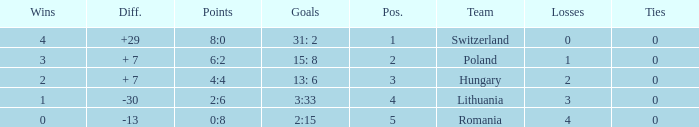Which team had fewer than 2 losses and a position number more than 1? Poland. 